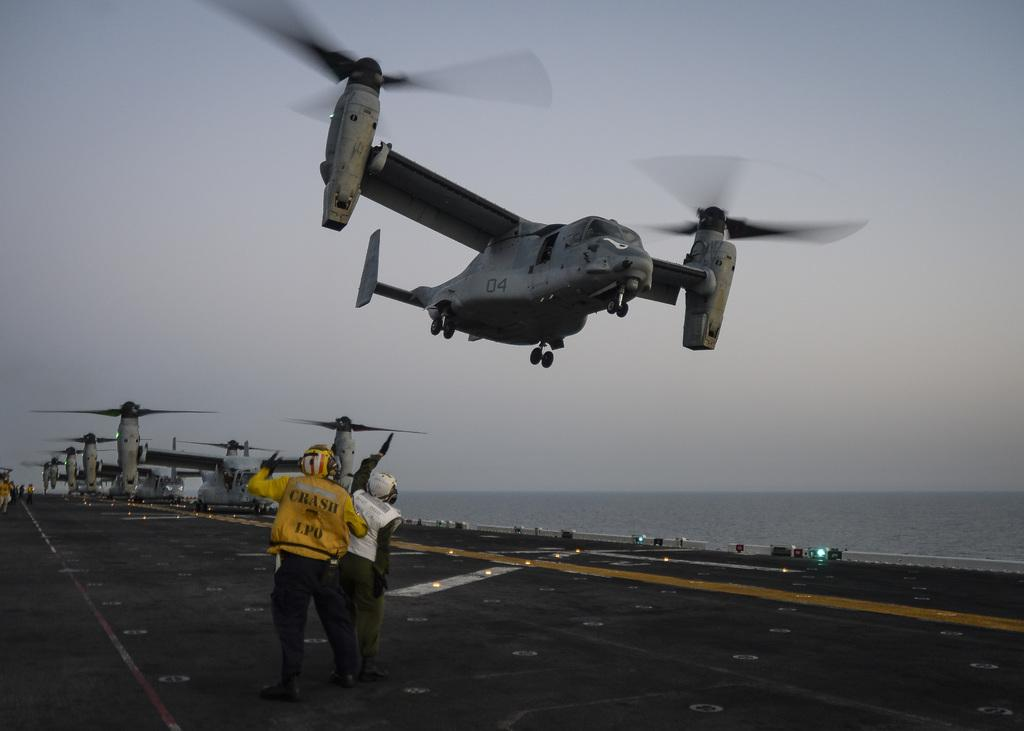What is happening in the sky in the image? There are fair fords in the air in the image. What are the people in the image doing? Two people are standing on the road in the image. What can be seen in the distance in the image? There is a sea visible in the background of the image. What else is visible in the background of the image? The sky is visible in the background of the image. What type of cart is being used to carry the bait in the image? There is no cart or bait present in the image. How is the cork being used in the image? There is no cork present in the image. 